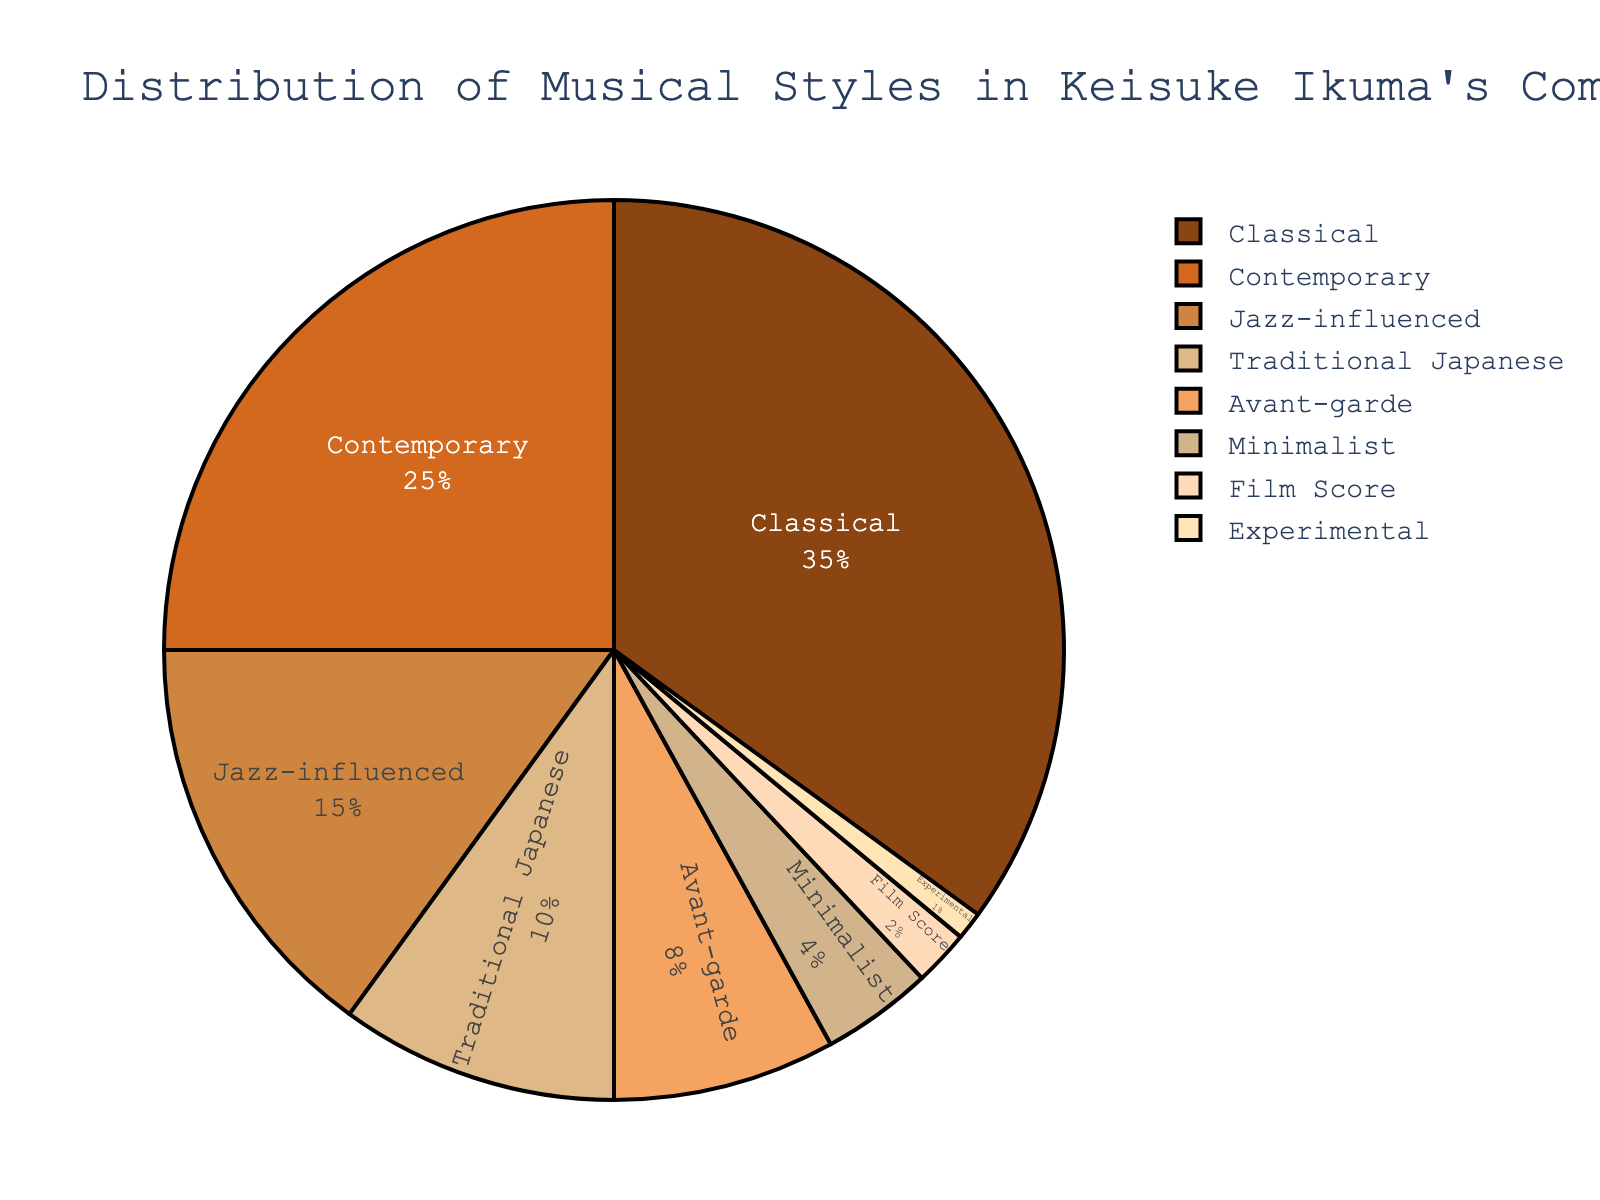what is the combined percentage of Contemporary and Jazz-influenced styles? The percentage of Contemporary style is 25% and the percentage of Jazz-influenced style is 15%. Adding them together gives 25% + 15% = 40%.
Answer: 40% Which musical style makes up the smallest percentage of Keisuke Ikuma's compositions? By looking at the pie chart, the smallest slice corresponds to the Experimental style, which has a percentage of 1%.
Answer: Experimental What is the difference in percentage between Classical and Avant-garde styles? The percentage for Classical is 35% and for Avant-garde is 8%. Subtracting Avant-garde from Classical gives 35% - 8% = 27%.
Answer: 27% How many styles have a percentage greater than 10% in the distribution? By examining the pie chart, the styles with percentages greater than 10% are Classical, Contemporary, and Jazz-influenced. There are 3 such styles.
Answer: 3 What percentage of the compositions is made up of styles classified as either Traditional Japanese or Minimalist? The percentage for Traditional Japanese is 10% and for Minimalist is 4%. Adding them together gives 10% + 4% = 14%.
Answer: 14% Does the Film Score style compose a larger percentage than Avant-garde? The percentage for Film Score is 2% and for Avant-garde is 8%. Comparing them, Avant-garde has a larger percentage.
Answer: No Which musical style occupies the largest area in the pie chart? The largest slice in the pie chart corresponds to the Classical style, which has a percentage of 35%.
Answer: Classical If you combine the percentages of Film Score and Experimental styles, how does it compare to the percentage for Minimalist? The combined percentage of Film Score and Experimental styles is 2% + 1% = 3%. The percentage for Minimalist is 4%. 3% is less than 4%.
Answer: Less than How does the combined percentage of the top three musical styles compare to the total percentage of all other styles? The top three styles are Classical (35%), Contemporary (25%), and Jazz-influenced (15%), totaling 35% + 25% + 15% = 75%. The other styles together are 25% (100% - 75%). The top three styles make up a larger percentage.
Answer: Larger What visual attribute distinguishes the style with the smallest percentage from the others? The Experimental style, which has the smallest percentage, is represented by the smallest slice in the pie chart.
Answer: Smallest slice 